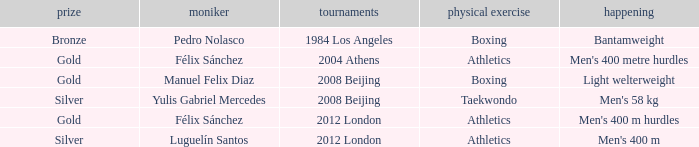Which Medal had a Name of félix sánchez, and a Games of 2012 london? Gold. 